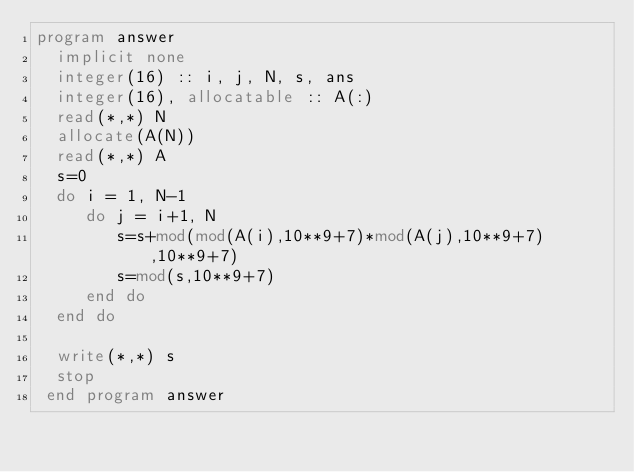Convert code to text. <code><loc_0><loc_0><loc_500><loc_500><_FORTRAN_>program answer
  implicit none
  integer(16) :: i, j, N, s, ans
  integer(16), allocatable :: A(:)
  read(*,*) N
  allocate(A(N))
  read(*,*) A
  s=0
  do i = 1, N-1
     do j = i+1, N
        s=s+mod(mod(A(i),10**9+7)*mod(A(j),10**9+7),10**9+7)
        s=mod(s,10**9+7)
     end do
  end do

  write(*,*) s
  stop
 end program answer</code> 